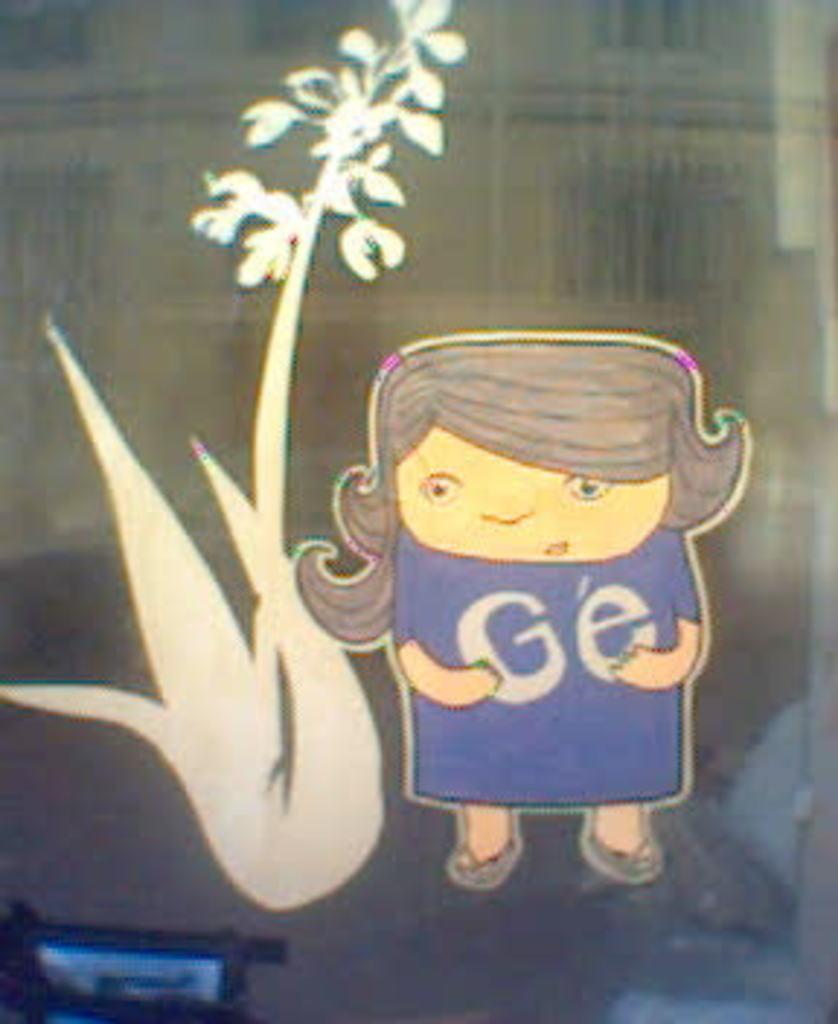Could you give a brief overview of what you see in this image? There is a sticker of an animated image of a person passed near a sticker of a plant on the glass. In the background, there are other objects. 